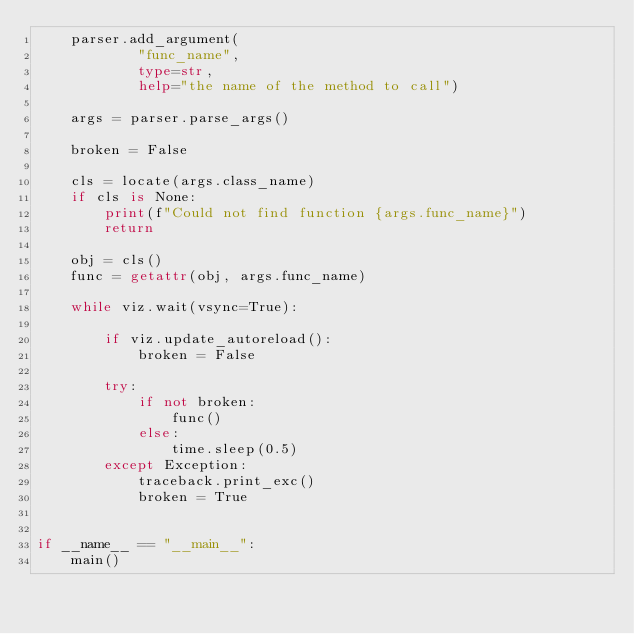Convert code to text. <code><loc_0><loc_0><loc_500><loc_500><_Python_>    parser.add_argument(
            "func_name",
            type=str,
            help="the name of the method to call")

    args = parser.parse_args()

    broken = False

    cls = locate(args.class_name)
    if cls is None:
        print(f"Could not find function {args.func_name}")
        return

    obj = cls()
    func = getattr(obj, args.func_name)

    while viz.wait(vsync=True):

        if viz.update_autoreload():
            broken = False

        try:
            if not broken:
                func()
            else:
                time.sleep(0.5)
        except Exception:
            traceback.print_exc()
            broken = True


if __name__ == "__main__":
    main()
</code> 